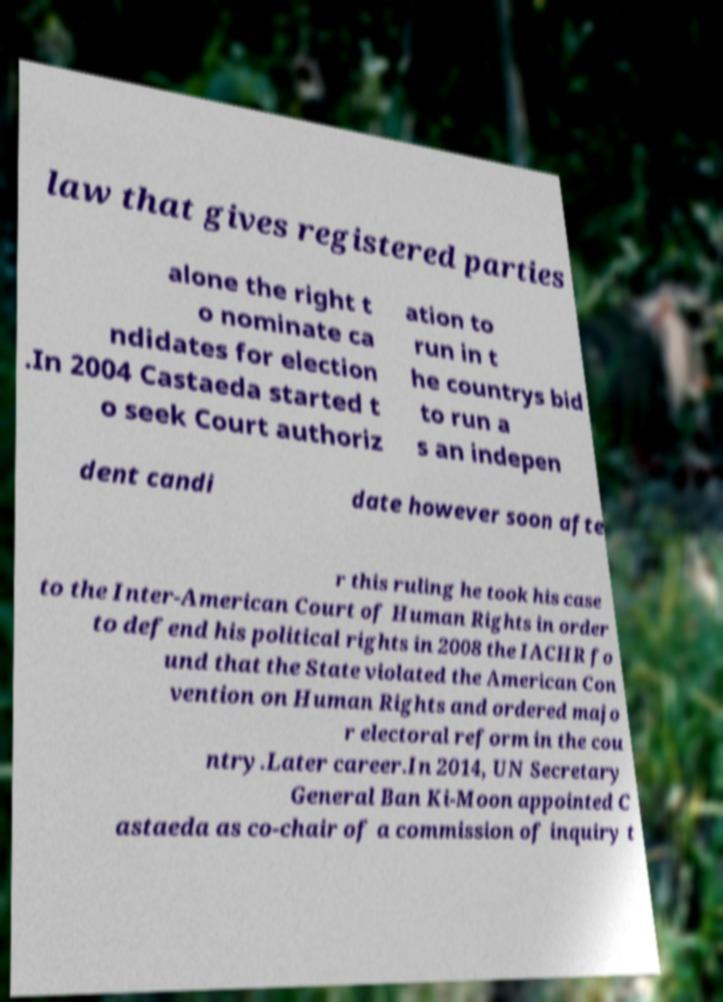I need the written content from this picture converted into text. Can you do that? law that gives registered parties alone the right t o nominate ca ndidates for election .In 2004 Castaeda started t o seek Court authoriz ation to run in t he countrys bid to run a s an indepen dent candi date however soon afte r this ruling he took his case to the Inter-American Court of Human Rights in order to defend his political rights in 2008 the IACHR fo und that the State violated the American Con vention on Human Rights and ordered majo r electoral reform in the cou ntry.Later career.In 2014, UN Secretary General Ban Ki-Moon appointed C astaeda as co-chair of a commission of inquiry t 